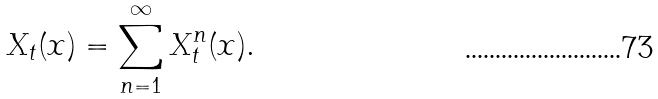Convert formula to latex. <formula><loc_0><loc_0><loc_500><loc_500>X _ { t } ( x ) = \sum ^ { \infty } _ { n = 1 } X ^ { n } _ { t } ( x ) .</formula> 